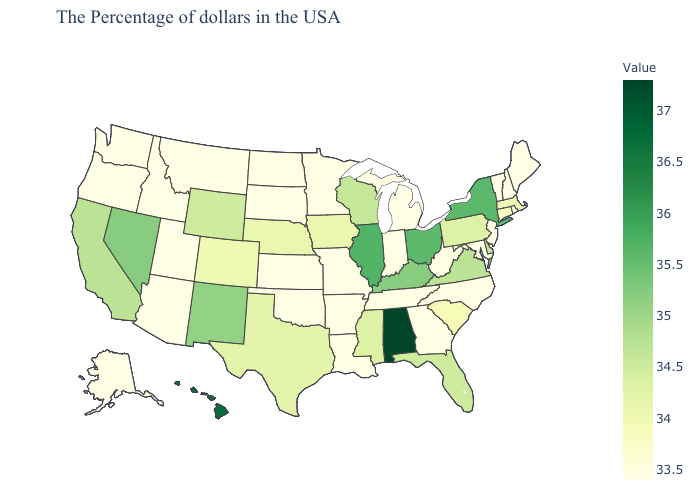Among the states that border Vermont , does New Hampshire have the lowest value?
Be succinct. Yes. Does the map have missing data?
Be succinct. No. Does New Hampshire have the highest value in the USA?
Keep it brief. No. Among the states that border New Hampshire , does Vermont have the highest value?
Answer briefly. No. 